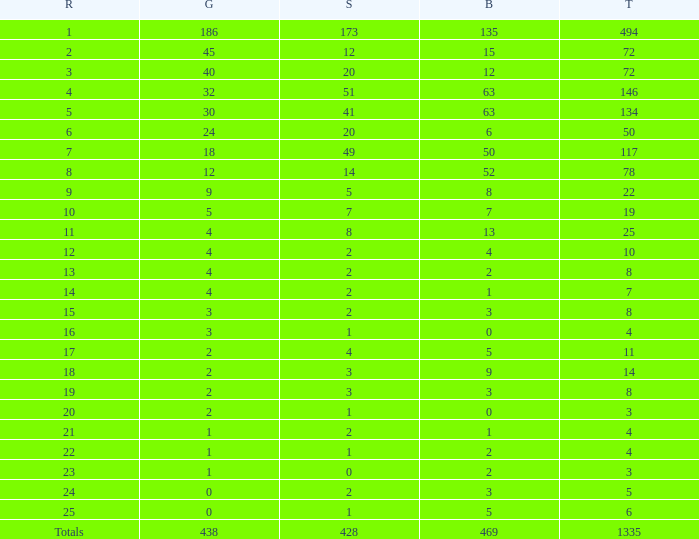What is the average number of gold medals when the total was 1335 medals, with more than 469 bronzes and more than 14 silvers? None. 